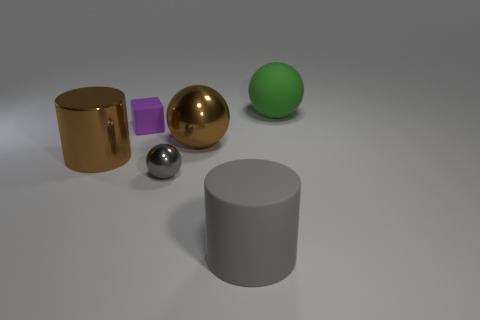Subtract all cubes. How many objects are left? 5 Subtract all gray spheres. How many spheres are left? 2 Subtract all metallic balls. How many balls are left? 1 Subtract 0 green blocks. How many objects are left? 6 Subtract 1 cylinders. How many cylinders are left? 1 Subtract all gray blocks. Subtract all yellow spheres. How many blocks are left? 1 Subtract all gray cylinders. How many red balls are left? 0 Subtract all large blue metallic blocks. Subtract all tiny gray metallic things. How many objects are left? 5 Add 1 large cylinders. How many large cylinders are left? 3 Add 1 small yellow rubber cubes. How many small yellow rubber cubes exist? 1 